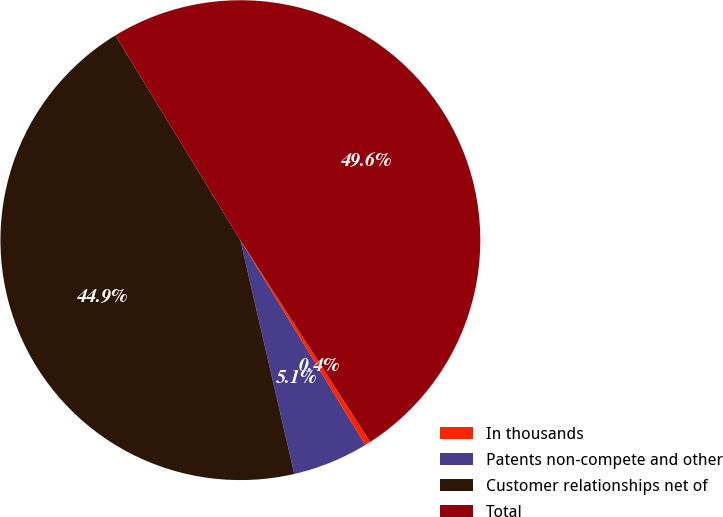Convert chart to OTSL. <chart><loc_0><loc_0><loc_500><loc_500><pie_chart><fcel>In thousands<fcel>Patents non-compete and other<fcel>Customer relationships net of<fcel>Total<nl><fcel>0.38%<fcel>5.11%<fcel>44.89%<fcel>49.62%<nl></chart> 